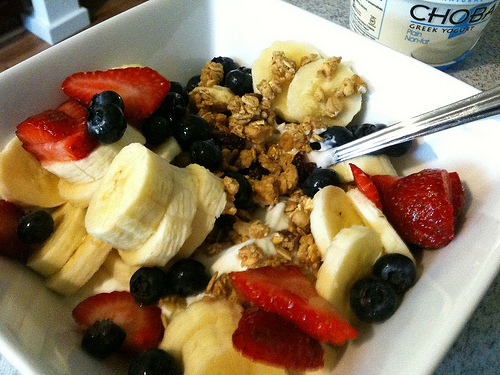<image>
Can you confirm if the shadow is next to the yogurt? Yes. The shadow is positioned adjacent to the yogurt, located nearby in the same general area. Is the fruits on the plate? Yes. Looking at the image, I can see the fruits is positioned on top of the plate, with the plate providing support. 